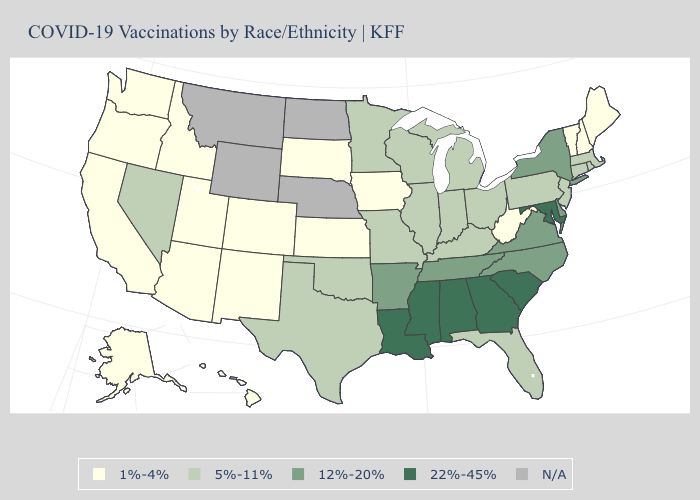Name the states that have a value in the range N/A?
Quick response, please. Montana, Nebraska, North Dakota, Wyoming. Name the states that have a value in the range 12%-20%?
Answer briefly. Arkansas, Delaware, New York, North Carolina, Tennessee, Virginia. Which states have the highest value in the USA?
Short answer required. Alabama, Georgia, Louisiana, Maryland, Mississippi, South Carolina. Does Ohio have the lowest value in the MidWest?
Answer briefly. No. What is the value of Louisiana?
Answer briefly. 22%-45%. Among the states that border Oregon , which have the lowest value?
Quick response, please. California, Idaho, Washington. Name the states that have a value in the range 1%-4%?
Write a very short answer. Alaska, Arizona, California, Colorado, Hawaii, Idaho, Iowa, Kansas, Maine, New Hampshire, New Mexico, Oregon, South Dakota, Utah, Vermont, Washington, West Virginia. What is the highest value in the Northeast ?
Keep it brief. 12%-20%. Name the states that have a value in the range 12%-20%?
Quick response, please. Arkansas, Delaware, New York, North Carolina, Tennessee, Virginia. Does the first symbol in the legend represent the smallest category?
Answer briefly. Yes. What is the value of Illinois?
Give a very brief answer. 5%-11%. Does New York have the highest value in the Northeast?
Concise answer only. Yes. Does California have the lowest value in the West?
Quick response, please. Yes. Among the states that border New Hampshire , which have the lowest value?
Quick response, please. Maine, Vermont. Name the states that have a value in the range 1%-4%?
Concise answer only. Alaska, Arizona, California, Colorado, Hawaii, Idaho, Iowa, Kansas, Maine, New Hampshire, New Mexico, Oregon, South Dakota, Utah, Vermont, Washington, West Virginia. 